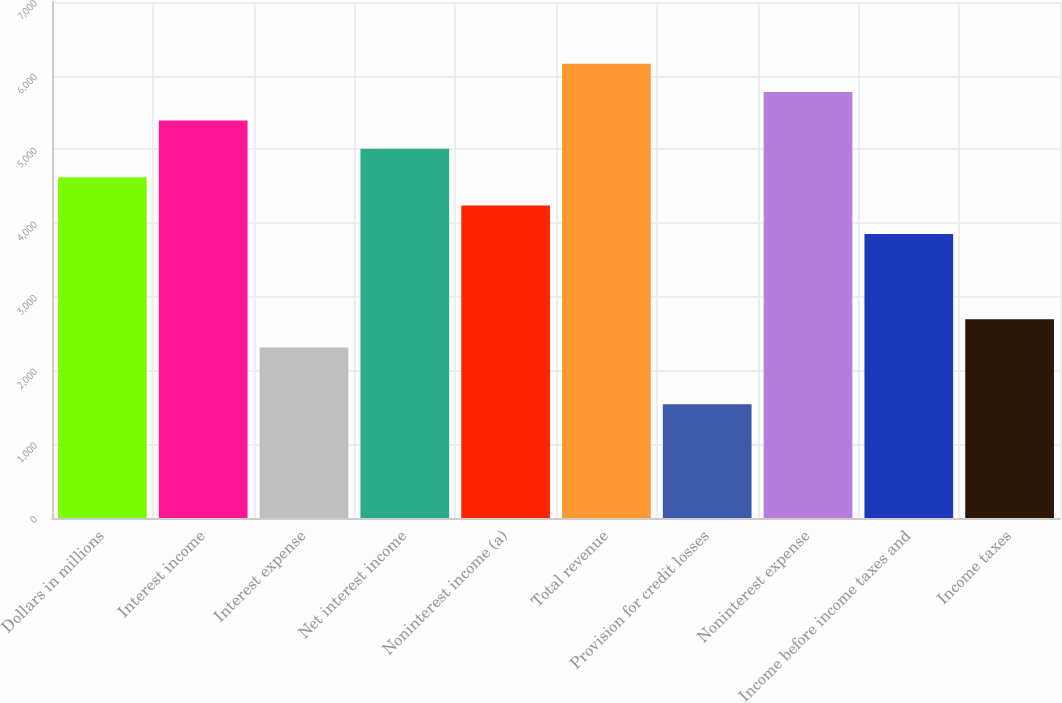Convert chart. <chart><loc_0><loc_0><loc_500><loc_500><bar_chart><fcel>Dollars in millions<fcel>Interest income<fcel>Interest expense<fcel>Net interest income<fcel>Noninterest income (a)<fcel>Total revenue<fcel>Provision for credit losses<fcel>Noninterest expense<fcel>Income before income taxes and<fcel>Income taxes<nl><fcel>4623.19<fcel>5393.41<fcel>2312.53<fcel>5008.3<fcel>4238.08<fcel>6163.63<fcel>1542.31<fcel>5778.52<fcel>3852.97<fcel>2697.64<nl></chart> 